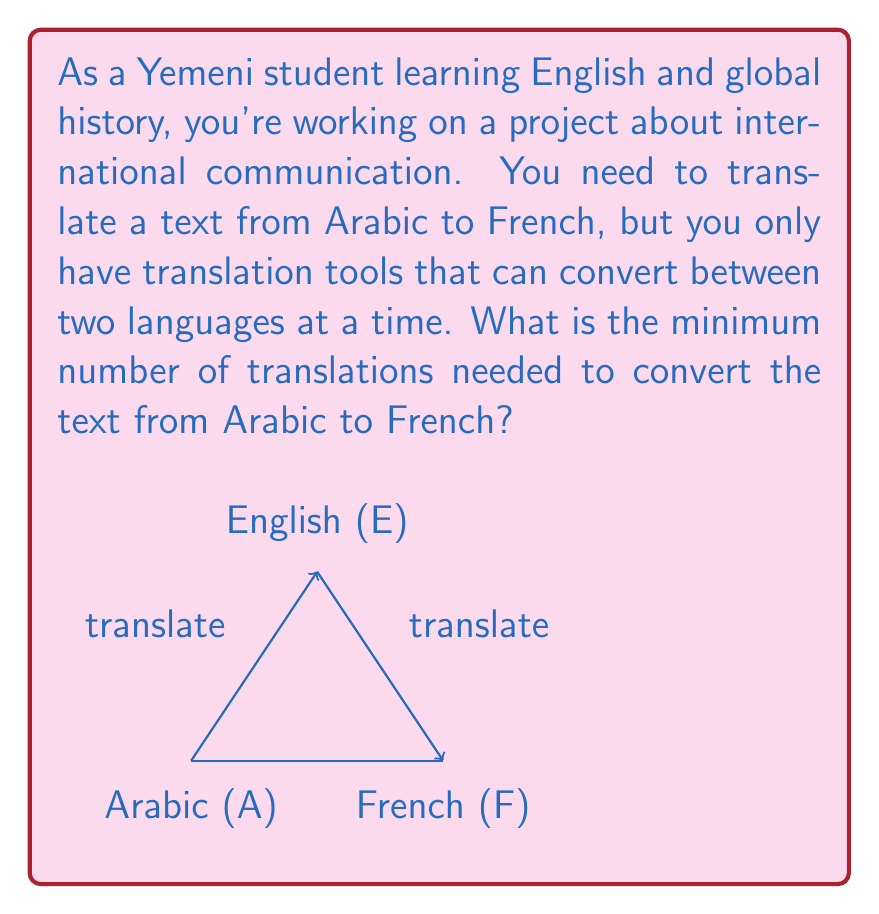Can you solve this math problem? Let's approach this step-by-step:

1) First, we need to understand the given information:
   - We start with a text in Arabic
   - We want to end up with the text in French
   - We can only translate between two languages at a time

2) Let's consider the possible paths:
   a) Arabic → French (directly)
   b) Arabic → English → French

3) The direct path from Arabic to French would be ideal, requiring only one translation. However, the question implies that we don't have a direct Arabic-to-French translation tool.

4) Therefore, we need to use English as an intermediate language:
   - Step 1: Translate from Arabic to English
   - Step 2: Translate from English to French

5) We can represent this as a graph problem:
   Let $A$ represent Arabic, $E$ represent English, and $F$ represent French.
   The path we need to take is: $A \rightarrow E \rightarrow F$

6) Counting the arrows in our path:
   $A \rightarrow E$ (1 translation)
   $E \rightarrow F$ (1 translation)

7) Total number of translations: $1 + 1 = 2$

Therefore, the minimum number of translations needed is 2.
Answer: 2 